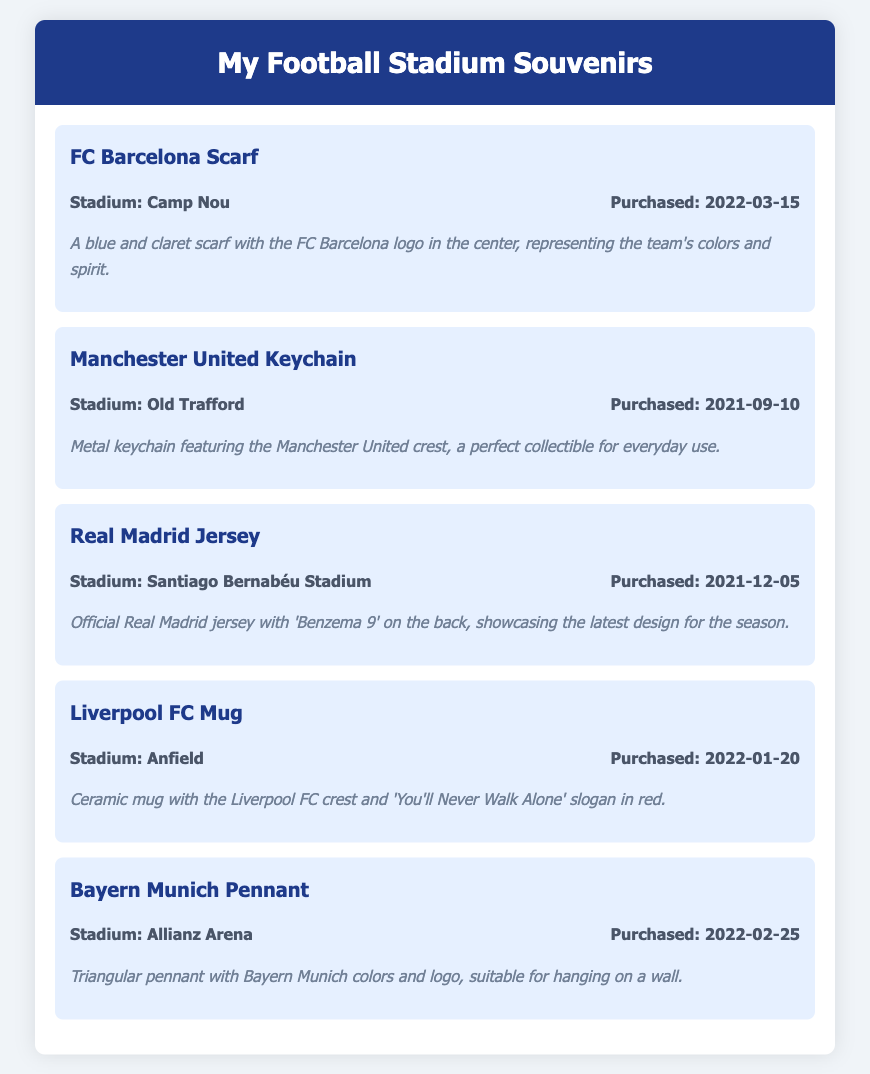What is the first souvenir listed? The first souvenir mentioned in the document is the FC Barcelona Scarf.
Answer: FC Barcelona Scarf How many souvenirs were purchased at the Camp Nou? Only one souvenir, the FC Barcelona Scarf, was purchased at the Camp Nou.
Answer: 1 What is the purchase date of the Manchester United Keychain? The document states that the Manchester United Keychain was purchased on September 10, 2021.
Answer: 2021-09-10 Which stadium is associated with the Liverpool FC Mug? The stadium associated with the Liverpool FC Mug is Anfield.
Answer: Anfield What type of item is the Bayern Munich souvenir? The Bayern Munich souvenir is a pennant.
Answer: Pennant Which souvenir has a specific player's name on it? The Real Madrid Jersey features the name 'Benzema 9' on it.
Answer: Benzema 9 What color is the scarf of the FC Barcelona? The FC Barcelona Scarf is blue and claret.
Answer: Blue and claret How many souvenirs are listed in total? The document lists a total of five souvenirs.
Answer: 5 